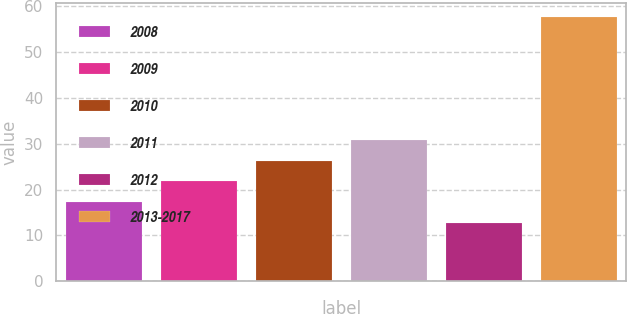<chart> <loc_0><loc_0><loc_500><loc_500><bar_chart><fcel>2008<fcel>2009<fcel>2010<fcel>2011<fcel>2012<fcel>2013-2017<nl><fcel>17.3<fcel>21.8<fcel>26.3<fcel>30.8<fcel>12.8<fcel>57.8<nl></chart> 